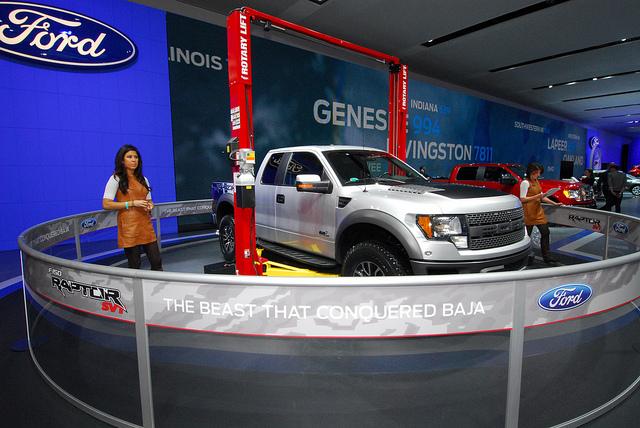What is the red device over the truck in the foreground?
Short answer required. Lift. Where is this display?
Write a very short answer. Car show. Is this at a dealership?
Write a very short answer. Yes. 